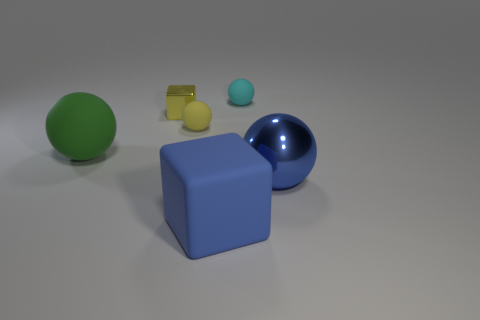Subtract all red spheres. Subtract all purple blocks. How many spheres are left? 4 Add 2 small cyan matte objects. How many objects exist? 8 Subtract all spheres. How many objects are left? 2 Add 1 small yellow metallic cubes. How many small yellow metallic cubes are left? 2 Add 1 big metal spheres. How many big metal spheres exist? 2 Subtract 1 green balls. How many objects are left? 5 Subtract all cyan matte balls. Subtract all tiny metallic objects. How many objects are left? 4 